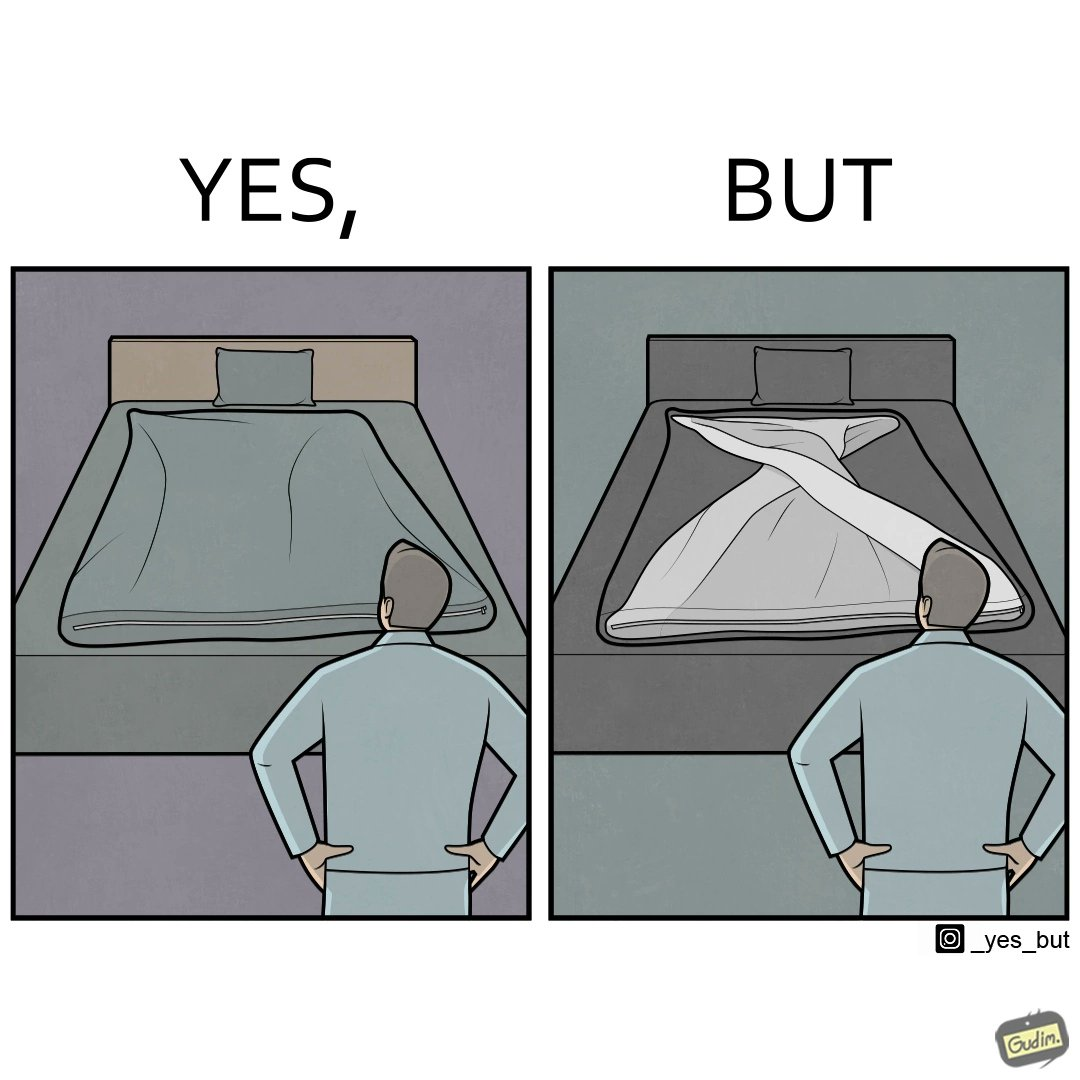Why is this image considered satirical? The image is funny because while the bed seems to be well made with the blanket on top, the actual blanket inside the blanket cover is twisted and not properly set. 